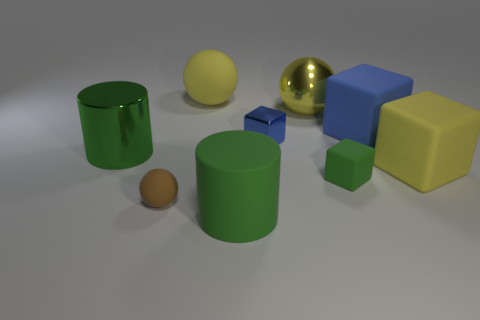What shape is the green object that is the same size as the green rubber cylinder?
Your answer should be very brief. Cylinder. What material is the cube that is the same color as the tiny shiny object?
Offer a terse response. Rubber. Are there any large metallic objects behind the big green metal object?
Offer a terse response. Yes. Does the small block in front of the blue metal thing have the same color as the tiny object that is left of the tiny blue object?
Give a very brief answer. No. Are there any big blue objects that have the same shape as the small blue metallic thing?
Ensure brevity in your answer.  Yes. What number of other objects are the same color as the matte cylinder?
Your response must be concise. 2. There is a big object that is in front of the rubber object to the right of the big matte block that is behind the blue shiny cube; what is its color?
Offer a very short reply. Green. Are there an equal number of tiny rubber things that are right of the large yellow shiny object and yellow matte things?
Your answer should be compact. No. Do the matte ball that is in front of the green metallic object and the tiny green thing have the same size?
Offer a very short reply. Yes. How many large blue objects are there?
Make the answer very short. 1. 